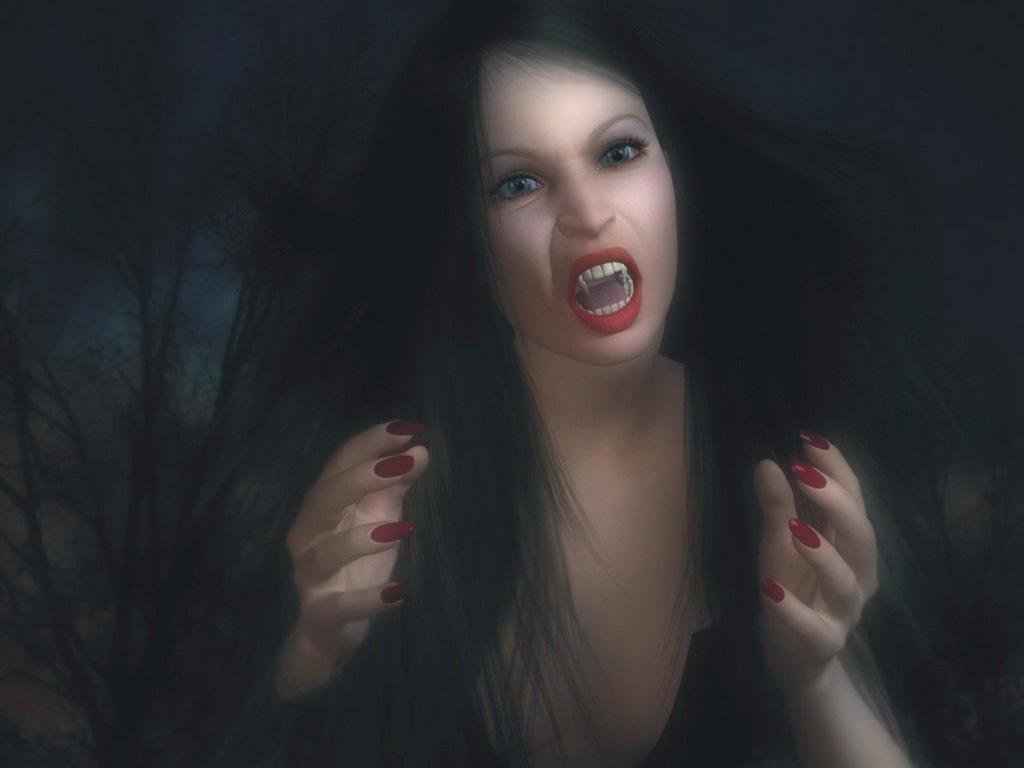Could you give a brief overview of what you see in this image? This is an animated image. Here I can see a woman. It seems like she is shouting. The background is in black color. 